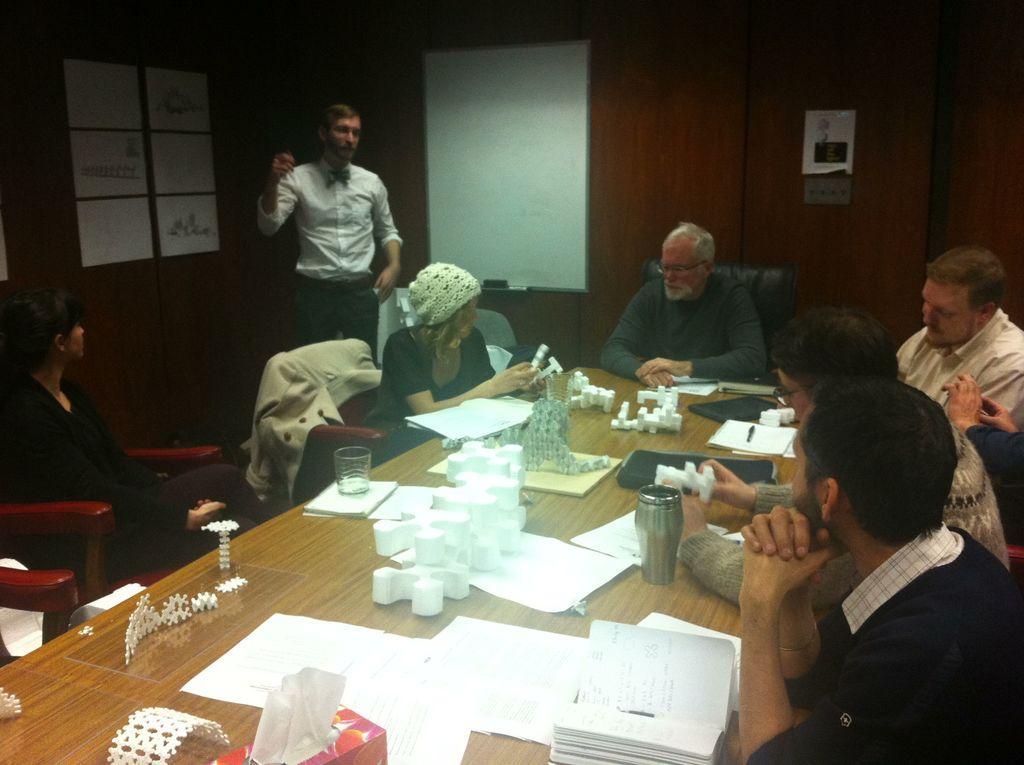Describe this image in one or two sentences. These persons are sitting on a chair. On this chair there is a jacket. On this table there is a glass, papers and things. A white board near this wall. Posters on wall. This person is standing, 